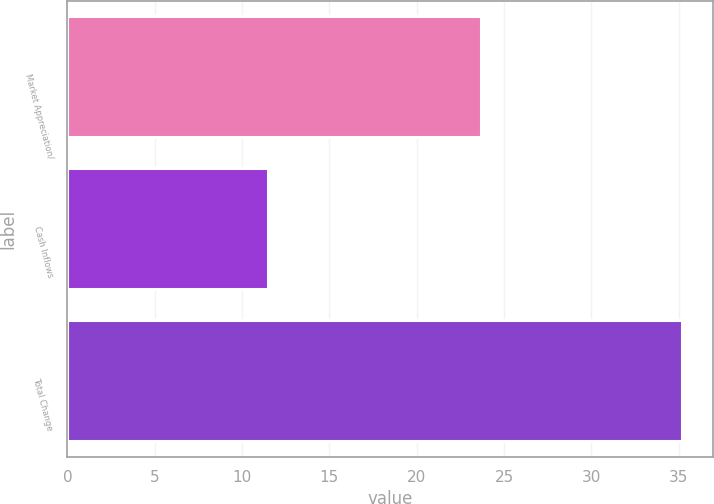Convert chart. <chart><loc_0><loc_0><loc_500><loc_500><bar_chart><fcel>Market Appreciation/<fcel>Cash Inflows<fcel>Total Change<nl><fcel>23.7<fcel>11.5<fcel>35.2<nl></chart> 